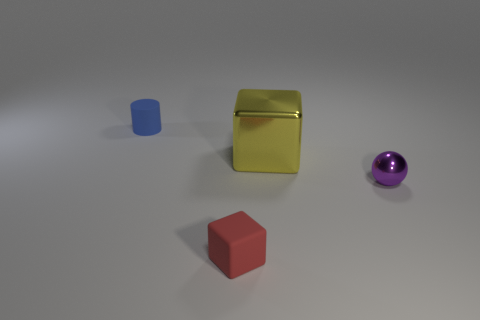Is there a small purple metallic thing?
Offer a terse response. Yes. There is a tiny blue object that is made of the same material as the red object; what is its shape?
Your response must be concise. Cylinder. There is a cube right of the red rubber object; what is it made of?
Your response must be concise. Metal. Do the thing that is on the left side of the red block and the large cube have the same color?
Provide a short and direct response. No. There is a shiny thing right of the block that is behind the red cube; what size is it?
Keep it short and to the point. Small. Is the number of small blue rubber cylinders in front of the small blue matte cylinder greater than the number of metal things?
Your answer should be very brief. No. Do the metal object to the left of the purple thing and the tiny purple sphere have the same size?
Offer a very short reply. No. What color is the small object that is behind the matte block and in front of the blue object?
Keep it short and to the point. Purple. What is the shape of the blue matte object that is the same size as the sphere?
Keep it short and to the point. Cylinder. Are there any other blocks that have the same color as the tiny cube?
Make the answer very short. No. 